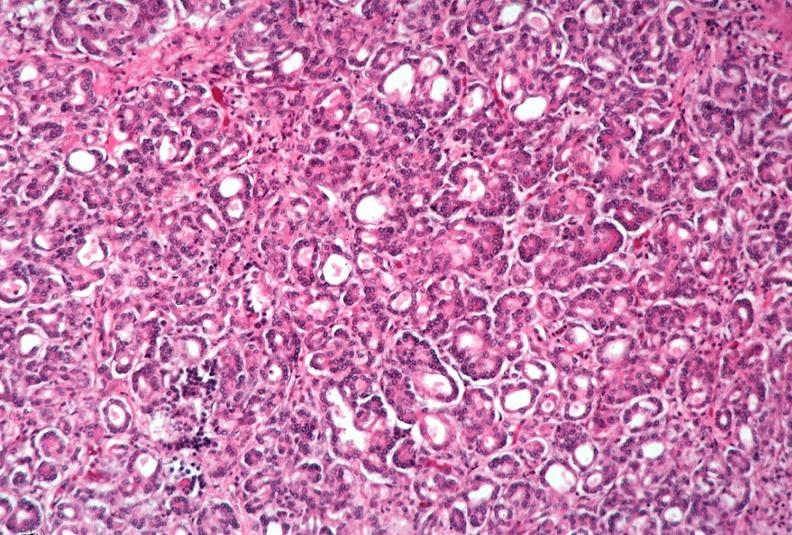what does this image show?
Answer the question using a single word or phrase. Pancreas 